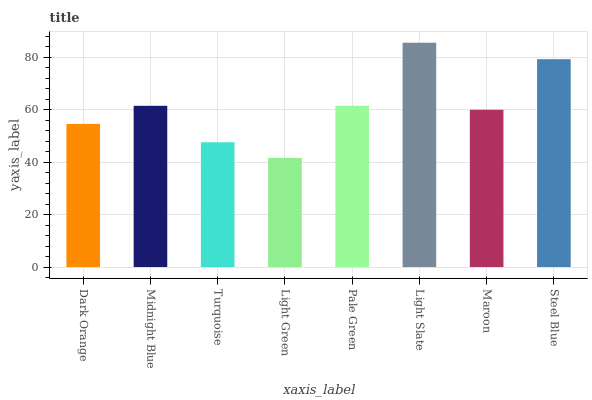Is Light Green the minimum?
Answer yes or no. Yes. Is Light Slate the maximum?
Answer yes or no. Yes. Is Midnight Blue the minimum?
Answer yes or no. No. Is Midnight Blue the maximum?
Answer yes or no. No. Is Midnight Blue greater than Dark Orange?
Answer yes or no. Yes. Is Dark Orange less than Midnight Blue?
Answer yes or no. Yes. Is Dark Orange greater than Midnight Blue?
Answer yes or no. No. Is Midnight Blue less than Dark Orange?
Answer yes or no. No. Is Midnight Blue the high median?
Answer yes or no. Yes. Is Maroon the low median?
Answer yes or no. Yes. Is Pale Green the high median?
Answer yes or no. No. Is Turquoise the low median?
Answer yes or no. No. 